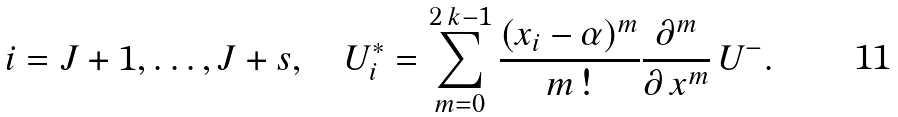Convert formula to latex. <formula><loc_0><loc_0><loc_500><loc_500>i = J + 1 , \dots , J + s , \quad U ^ { * } _ { i } = \sum _ { m = 0 } ^ { 2 \, k - 1 } \frac { ( x _ { i } - \alpha ) ^ { m } } { m \, ! } \frac { \partial ^ { m } } { \partial \, x ^ { m } } \, U ^ { - } .</formula> 